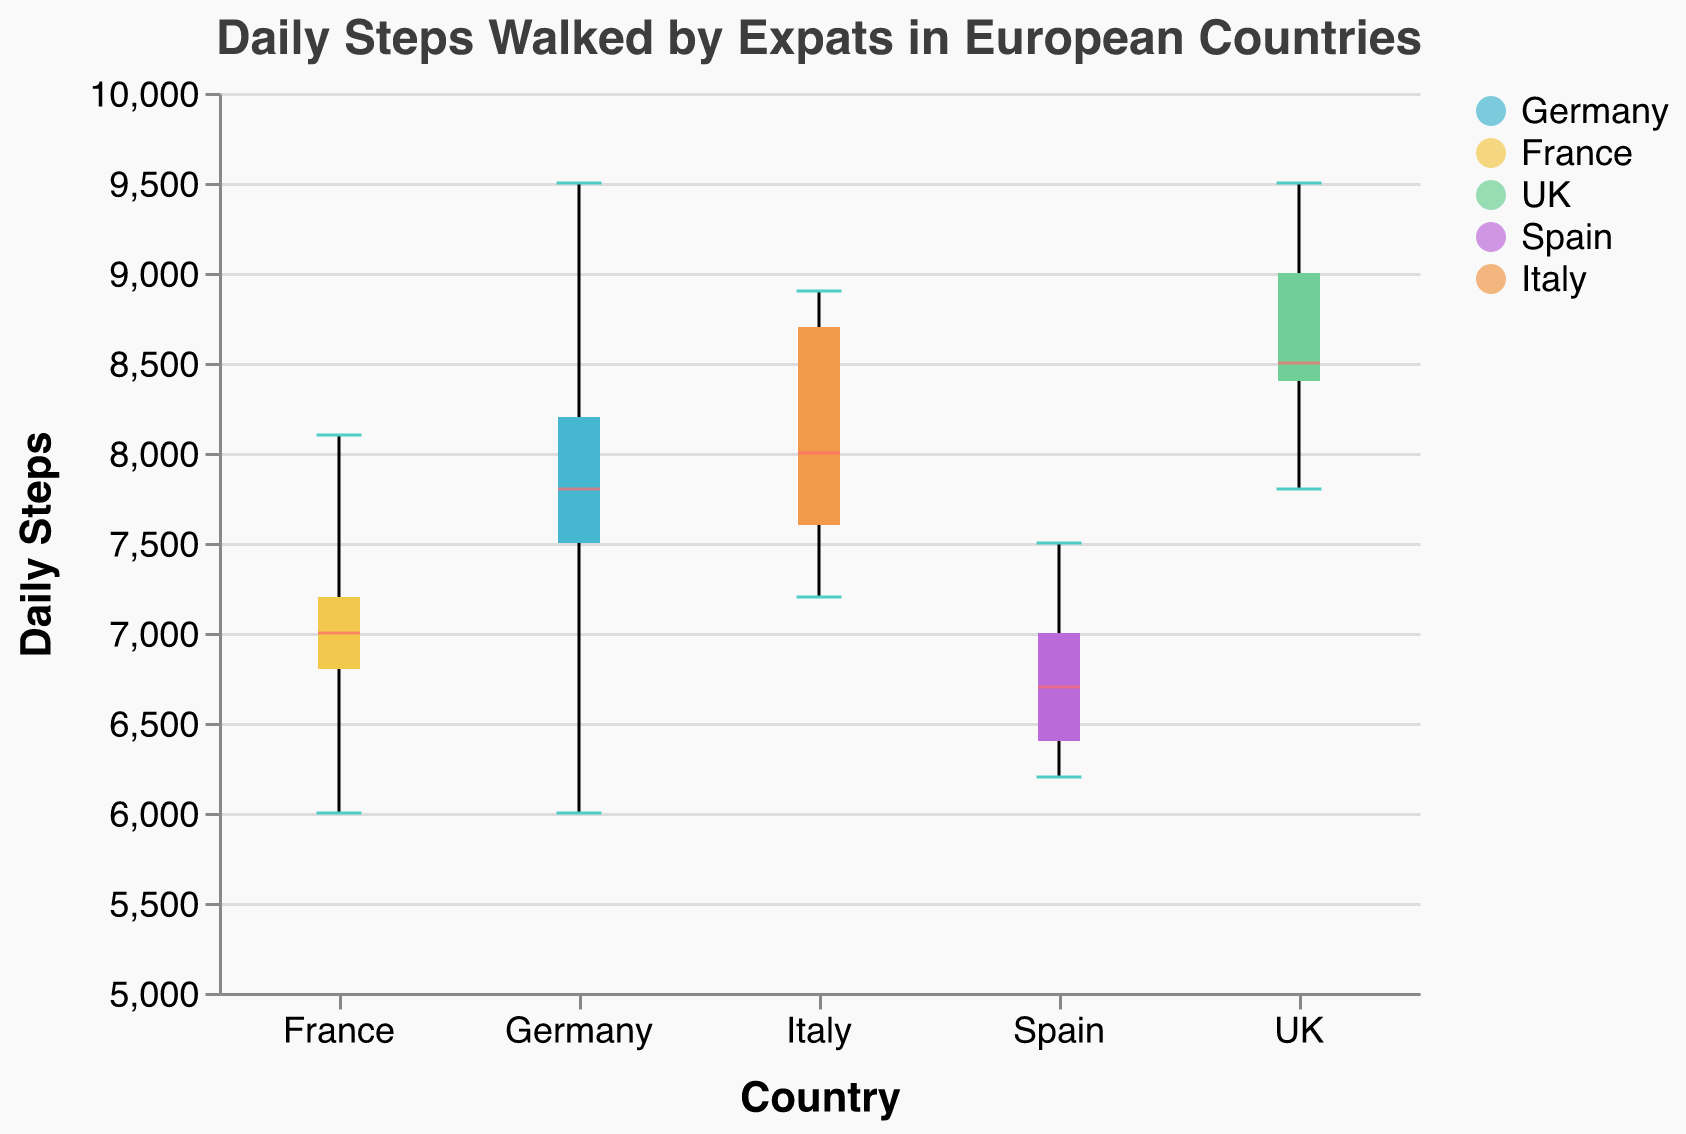What is the range of daily steps walked by expats in Germany? The box plot for Germany shows the minimum and maximum values. The minimum is 6000, and the maximum is 9500. Thus, the range is 9500 - 6000.
Answer: 3500 What is the median daily steps walked by expats in the UK? The red line in the box plot indicates the median value for the UK. It is around the midpoint of the distribution.
Answer: 8500 Which country has the highest median daily steps? By observing the red line indicating the median across all countries, the UK has the highest median value among the countries.
Answer: UK What is the interquartile range (IQR) of daily steps walked by expats in France? The IQR is the difference between the third quartile (Q3) and the first quartile (Q1) of the daily steps. For France, the box extends roughly from 6800 (Q1) to 7200 (Q3). Thus IQR = Q3 - Q1.
Answer: 400 What is the maximum daily steps walked by expats in Spain? The maximum is indicated by the top whisker of the box plot for Spain, which is 7500.
Answer: 7500 Which country shows the widest spread in the data for daily steps? The country with the widest spread will have the largest range from the bottom whisker to the top whisker. Looking at the whisker lengths across the countries, Germany has the widest spread from 6000 to 9500.
Answer: Germany Are there any outliers in the data across all countries? Outliers in a box plot are typically represented by dots beyond the whiskers. None of the box plots across any country show dots.
Answer: No What is the minimum daily steps walked by expats in Italy? The minimum is indicated by the bottom whisker for the Italy box plot, which is 7200.
Answer: 7200 Which country has the smallest interquartile range (IQR)? The country with the smallest difference between Q3 and Q1 (length of the box) will have the smallest IQR. By comparing the boxes, Spain shows the smallest IQR.
Answer: Spain 